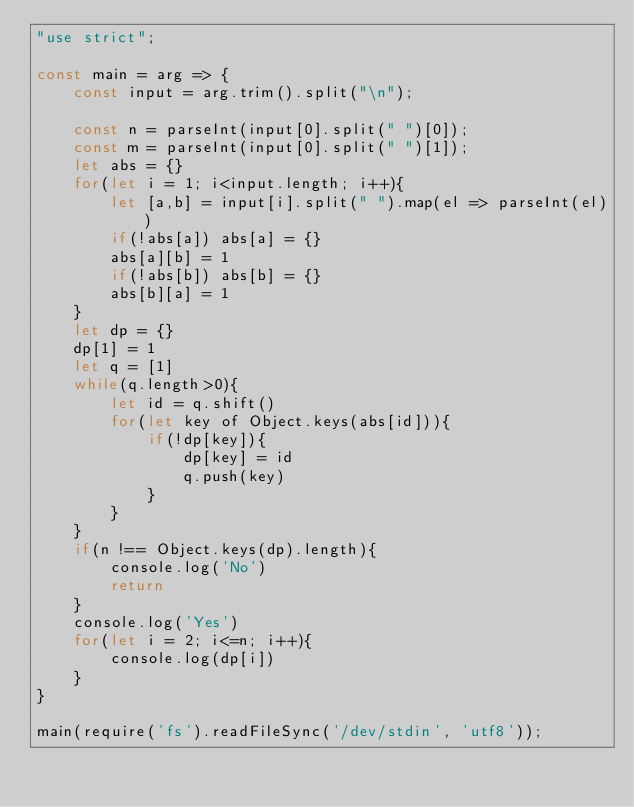<code> <loc_0><loc_0><loc_500><loc_500><_JavaScript_>"use strict";

const main = arg => {
    const input = arg.trim().split("\n");

    const n = parseInt(input[0].split(" ")[0]);
    const m = parseInt(input[0].split(" ")[1]);
    let abs = {}
    for(let i = 1; i<input.length; i++){
        let [a,b] = input[i].split(" ").map(el => parseInt(el))
        if(!abs[a]) abs[a] = {}
        abs[a][b] = 1
        if(!abs[b]) abs[b] = {}
        abs[b][a] = 1
    }
    let dp = {}
    dp[1] = 1
    let q = [1]
    while(q.length>0){
        let id = q.shift()
        for(let key of Object.keys(abs[id])){
            if(!dp[key]){
                dp[key] = id
                q.push(key)
            }
        }
    }
    if(n !== Object.keys(dp).length){
        console.log('No')
        return
    }
    console.log('Yes')
    for(let i = 2; i<=n; i++){
        console.log(dp[i])
    } 
}

main(require('fs').readFileSync('/dev/stdin', 'utf8'));  
</code> 